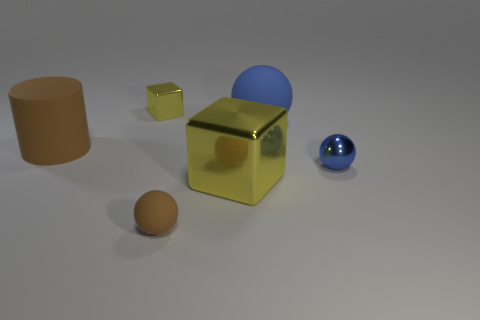Subtract all gray cylinders. How many blue balls are left? 2 Add 3 large brown matte objects. How many objects exist? 9 Subtract all brown rubber balls. How many balls are left? 2 Subtract all cubes. How many objects are left? 4 Add 2 tiny blue things. How many tiny blue things are left? 3 Add 5 small brown objects. How many small brown objects exist? 6 Subtract 0 purple blocks. How many objects are left? 6 Subtract all blue cylinders. Subtract all blue cubes. How many cylinders are left? 1 Subtract all brown cylinders. Subtract all big cylinders. How many objects are left? 4 